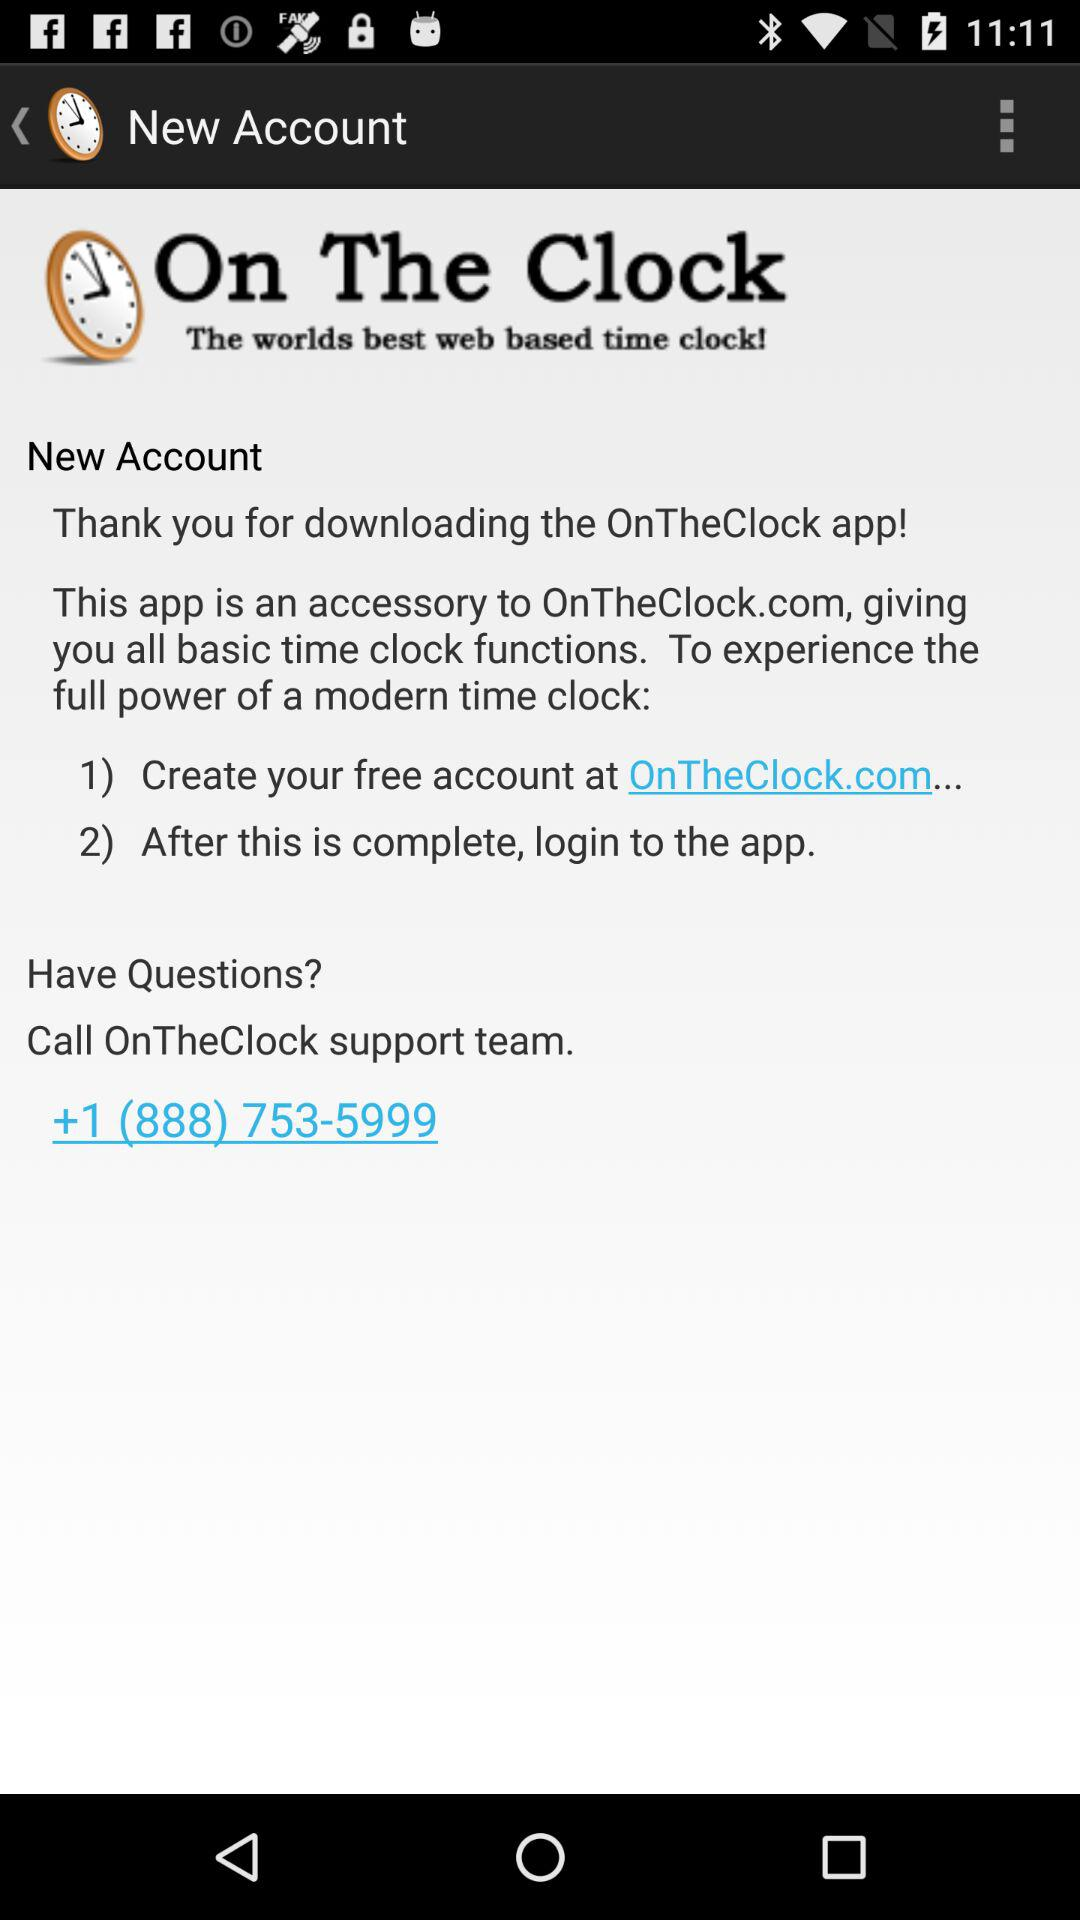What is the contact number of the "OnTheClock" support team? The contact number of the "OnTheClock" support team is +1 (888) 753-5999. 